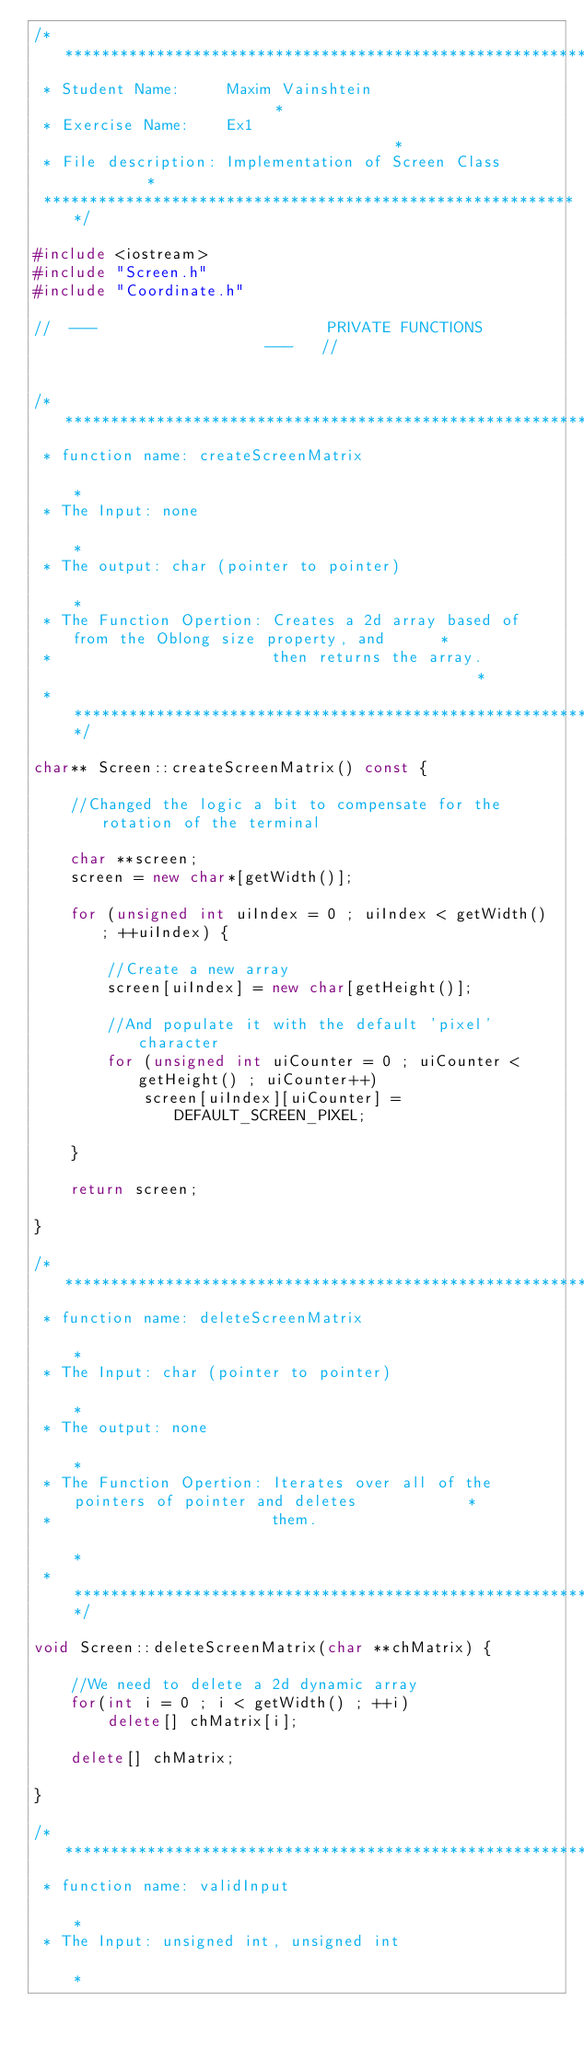Convert code to text. <code><loc_0><loc_0><loc_500><loc_500><_C++_>/************************************************************
 * Student Name:     Maxim Vainshtein                       *
 * Exercise Name:    Ex1                                    *
 * File description: Implementation of Screen Class         *
 ***********************************************************/

#include <iostream>
#include "Screen.h"
#include "Coordinate.h"

//  ---                         PRIVATE FUNCTIONS                       ---   //


/**********************************************************************************************
 * function name: createScreenMatrix                                                          *
 * The Input: none                                                                            *
 * The output: char (pointer to pointer)                                                      *
 * The Function Opertion: Creates a 2d array based of from the Oblong size property, and      *
 *                        then returns the array.                                             *
 * *******************************************************************************************/

char** Screen::createScreenMatrix() const {
    
    //Changed the logic a bit to compensate for the rotation of the terminal
    
    char **screen;
    screen = new char*[getWidth()];
    
    for (unsigned int uiIndex = 0 ; uiIndex < getWidth() ; ++uiIndex) {
        
        //Create a new array
        screen[uiIndex] = new char[getHeight()];
        
        //And populate it with the default 'pixel' character
        for (unsigned int uiCounter = 0 ; uiCounter < getHeight() ; uiCounter++)
            screen[uiIndex][uiCounter] = DEFAULT_SCREEN_PIXEL;
        
    }
    
    return screen;
    
}

/**********************************************************************************************
 * function name: deleteScreenMatrix                                                          *
 * The Input: char (pointer to pointer)                                                       *
 * The output: none                                                                           *
 * The Function Opertion: Iterates over all of the pointers of pointer and deletes            *
 *                        them.                                                               *
 * *******************************************************************************************/

void Screen::deleteScreenMatrix(char **chMatrix) {
    
    //We need to delete a 2d dynamic array
    for(int i = 0 ; i < getWidth() ; ++i)
        delete[] chMatrix[i];
    
    delete[] chMatrix;
    
}

/**********************************************************************************************
 * function name: validInput                                                                  *
 * The Input: unsigned int, unsigned int                                                      *</code> 